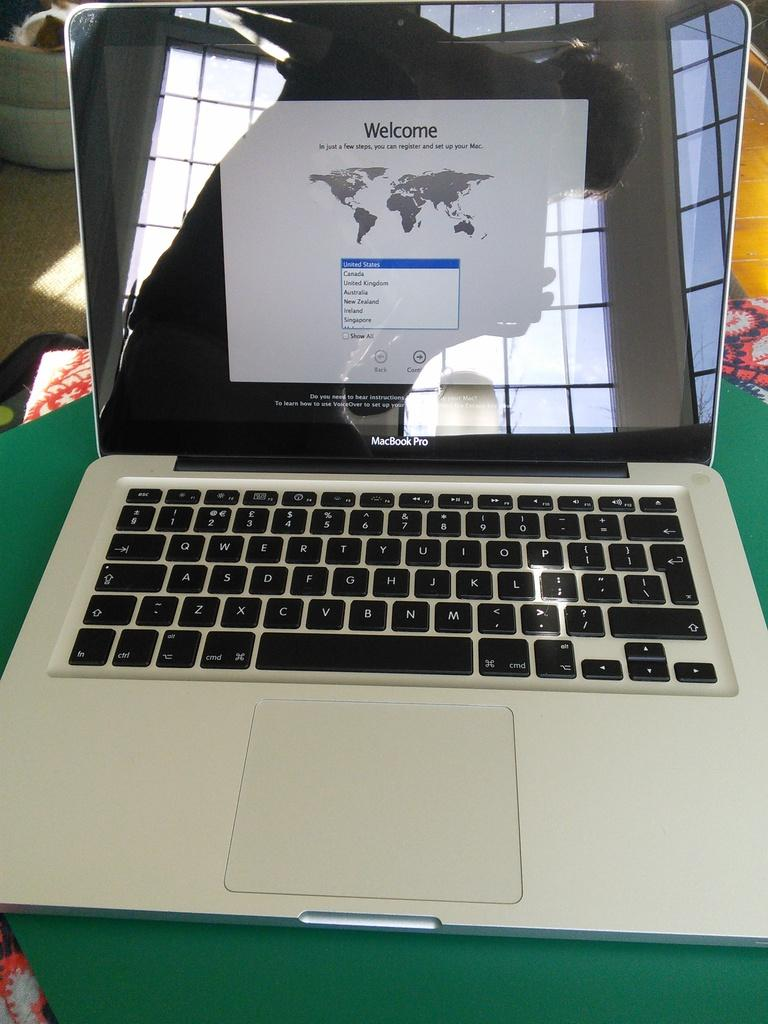<image>
Summarize the visual content of the image. A laptop that has a welcome sign attached to it 